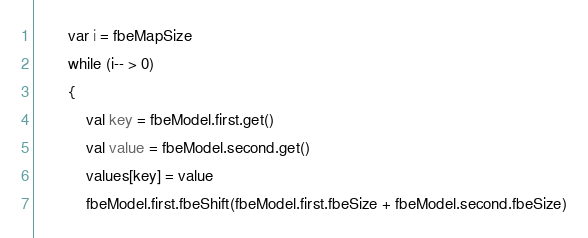<code> <loc_0><loc_0><loc_500><loc_500><_Kotlin_>        var i = fbeMapSize
        while (i-- > 0)
        {
            val key = fbeModel.first.get()
            val value = fbeModel.second.get()
            values[key] = value
            fbeModel.first.fbeShift(fbeModel.first.fbeSize + fbeModel.second.fbeSize)</code> 